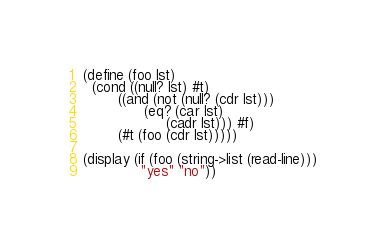<code> <loc_0><loc_0><loc_500><loc_500><_Scheme_>(define (foo lst)
  (cond ((null? lst) #t)
        ((and (not (null? (cdr lst)))
              (eq? (car lst)
                   (cadr lst))) #f)
        (#t (foo (cdr lst)))))

(display (if (foo (string->list (read-line)))
             "yes" "no"))
</code> 